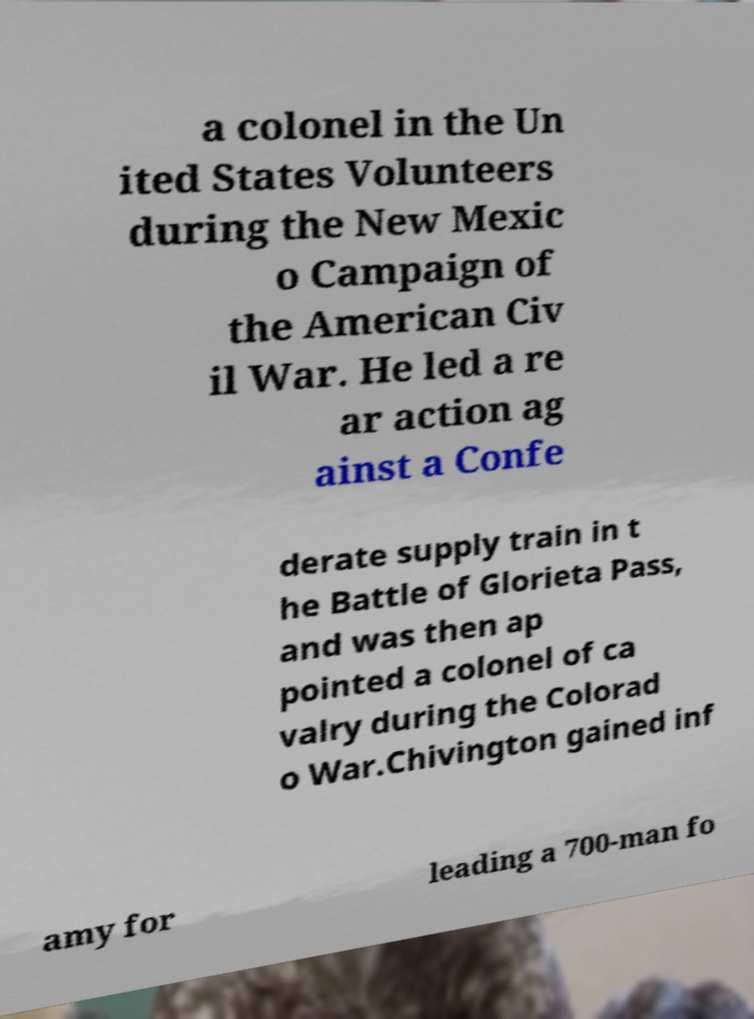I need the written content from this picture converted into text. Can you do that? a colonel in the Un ited States Volunteers during the New Mexic o Campaign of the American Civ il War. He led a re ar action ag ainst a Confe derate supply train in t he Battle of Glorieta Pass, and was then ap pointed a colonel of ca valry during the Colorad o War.Chivington gained inf amy for leading a 700-man fo 